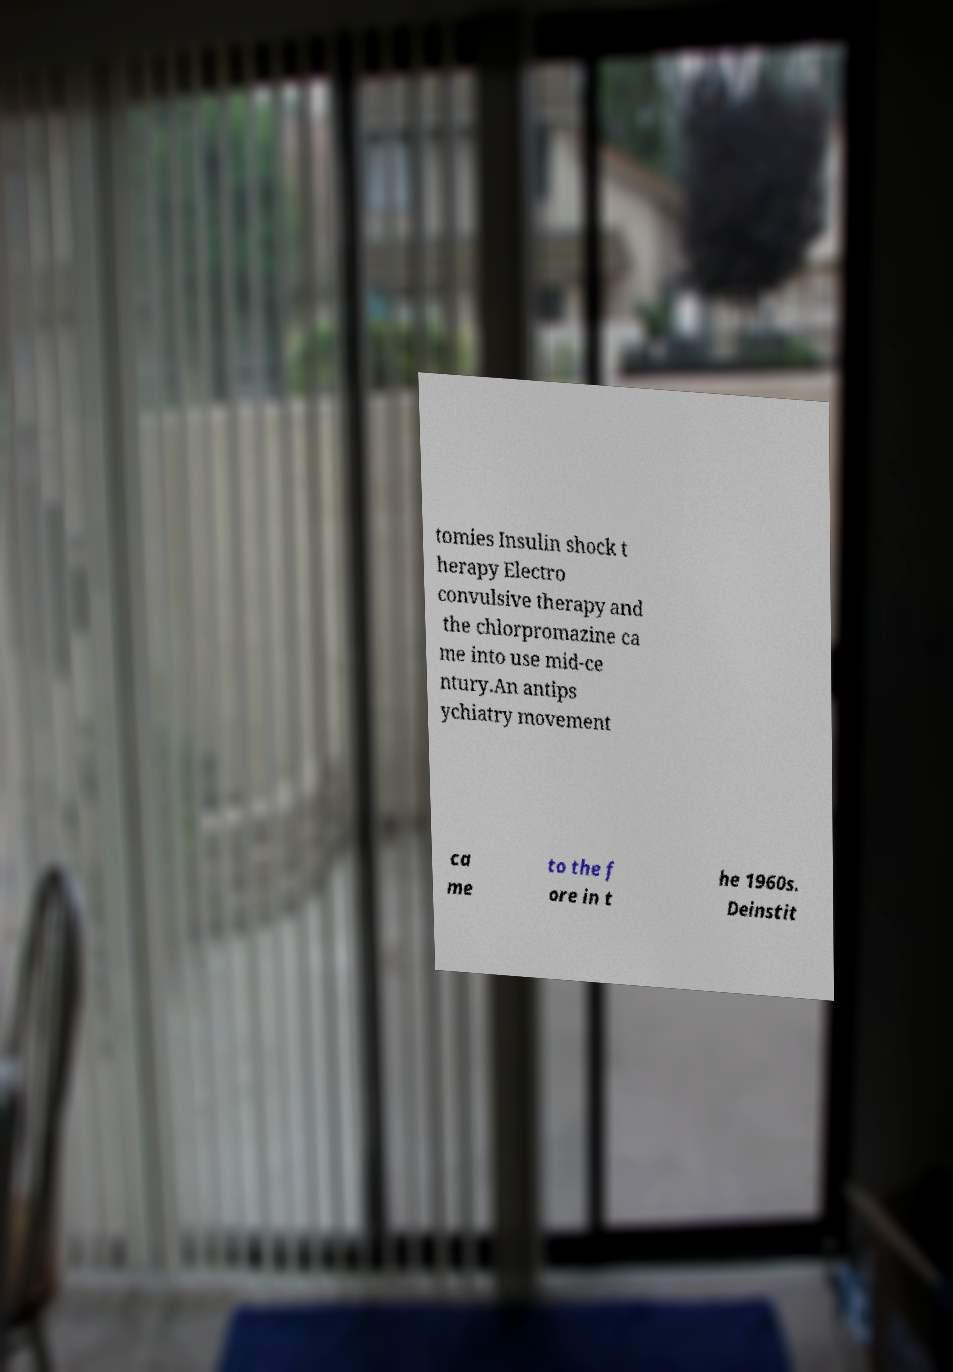Could you extract and type out the text from this image? tomies Insulin shock t herapy Electro convulsive therapy and the chlorpromazine ca me into use mid-ce ntury.An antips ychiatry movement ca me to the f ore in t he 1960s. Deinstit 